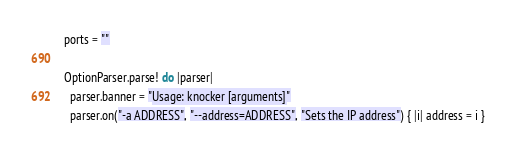Convert code to text. <code><loc_0><loc_0><loc_500><loc_500><_Crystal_>  ports = ""

  OptionParser.parse! do |parser|
    parser.banner = "Usage: knocker [arguments]"
    parser.on("-a ADDRESS", "--address=ADDRESS", "Sets the IP address") { |i| address = i }</code> 